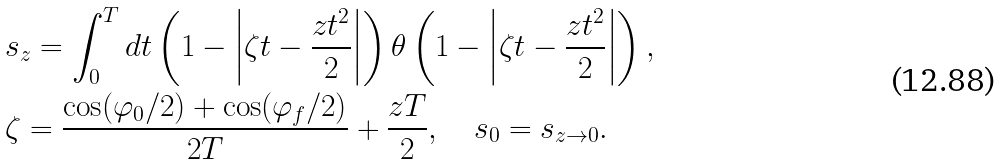<formula> <loc_0><loc_0><loc_500><loc_500>& s _ { z } = \int _ { 0 } ^ { T } d t \left ( 1 - \left | \zeta t - \frac { z t ^ { 2 } } { 2 } \right | \right ) \theta \left ( 1 - \left | \zeta t - \frac { z t ^ { 2 } } { 2 } \right | \right ) , \\ & \zeta = \frac { \cos ( \varphi _ { 0 } / 2 ) + \cos ( \varphi _ { f } / 2 ) } { 2 T } + \frac { z T } { 2 } , \quad s _ { 0 } = s _ { z \to 0 } .</formula> 